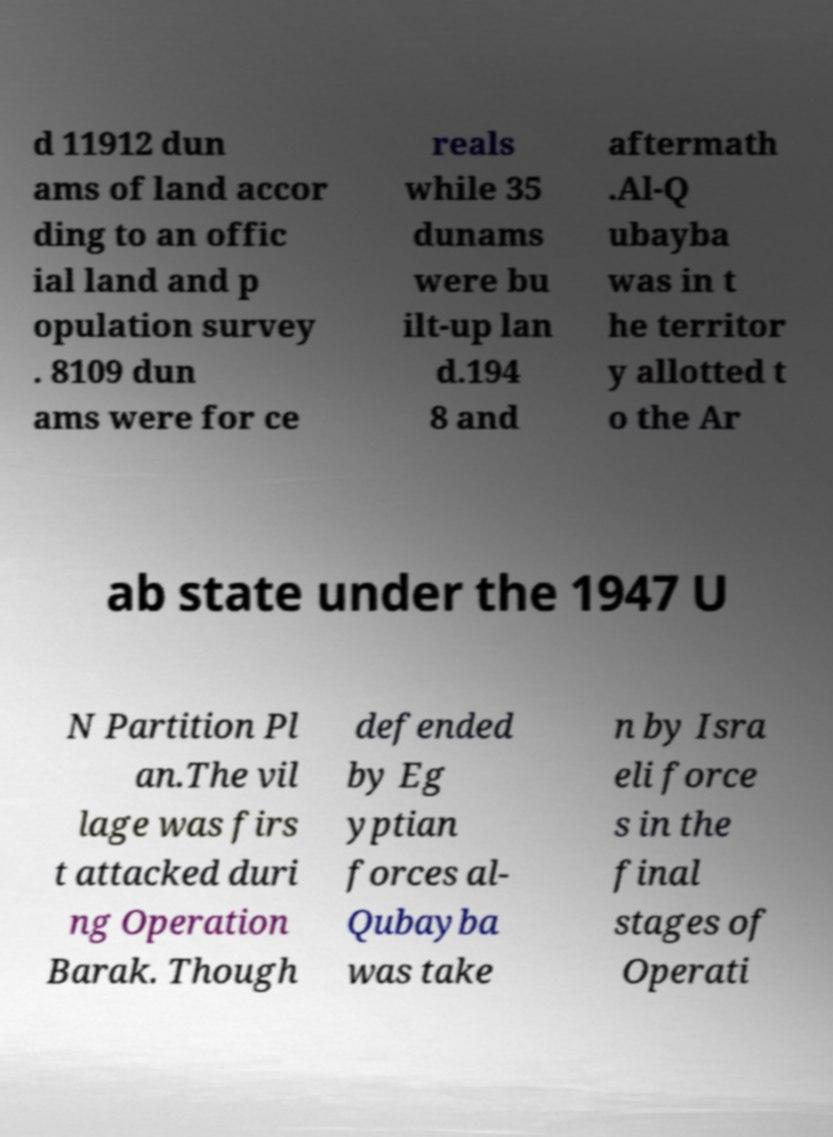Could you assist in decoding the text presented in this image and type it out clearly? d 11912 dun ams of land accor ding to an offic ial land and p opulation survey . 8109 dun ams were for ce reals while 35 dunams were bu ilt-up lan d.194 8 and aftermath .Al-Q ubayba was in t he territor y allotted t o the Ar ab state under the 1947 U N Partition Pl an.The vil lage was firs t attacked duri ng Operation Barak. Though defended by Eg yptian forces al- Qubayba was take n by Isra eli force s in the final stages of Operati 